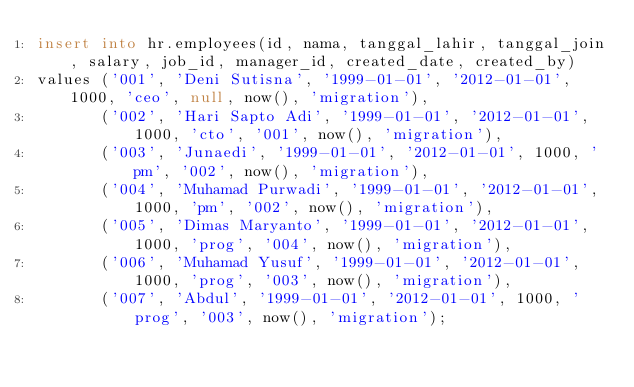<code> <loc_0><loc_0><loc_500><loc_500><_SQL_>insert into hr.employees(id, nama, tanggal_lahir, tanggal_join, salary, job_id, manager_id, created_date, created_by)
values ('001', 'Deni Sutisna', '1999-01-01', '2012-01-01', 1000, 'ceo', null, now(), 'migration'),
       ('002', 'Hari Sapto Adi', '1999-01-01', '2012-01-01', 1000, 'cto', '001', now(), 'migration'),
       ('003', 'Junaedi', '1999-01-01', '2012-01-01', 1000, 'pm', '002', now(), 'migration'),
       ('004', 'Muhamad Purwadi', '1999-01-01', '2012-01-01', 1000, 'pm', '002', now(), 'migration'),
       ('005', 'Dimas Maryanto', '1999-01-01', '2012-01-01', 1000, 'prog', '004', now(), 'migration'),
       ('006', 'Muhamad Yusuf', '1999-01-01', '2012-01-01', 1000, 'prog', '003', now(), 'migration'),
       ('007', 'Abdul', '1999-01-01', '2012-01-01', 1000, 'prog', '003', now(), 'migration');
</code> 